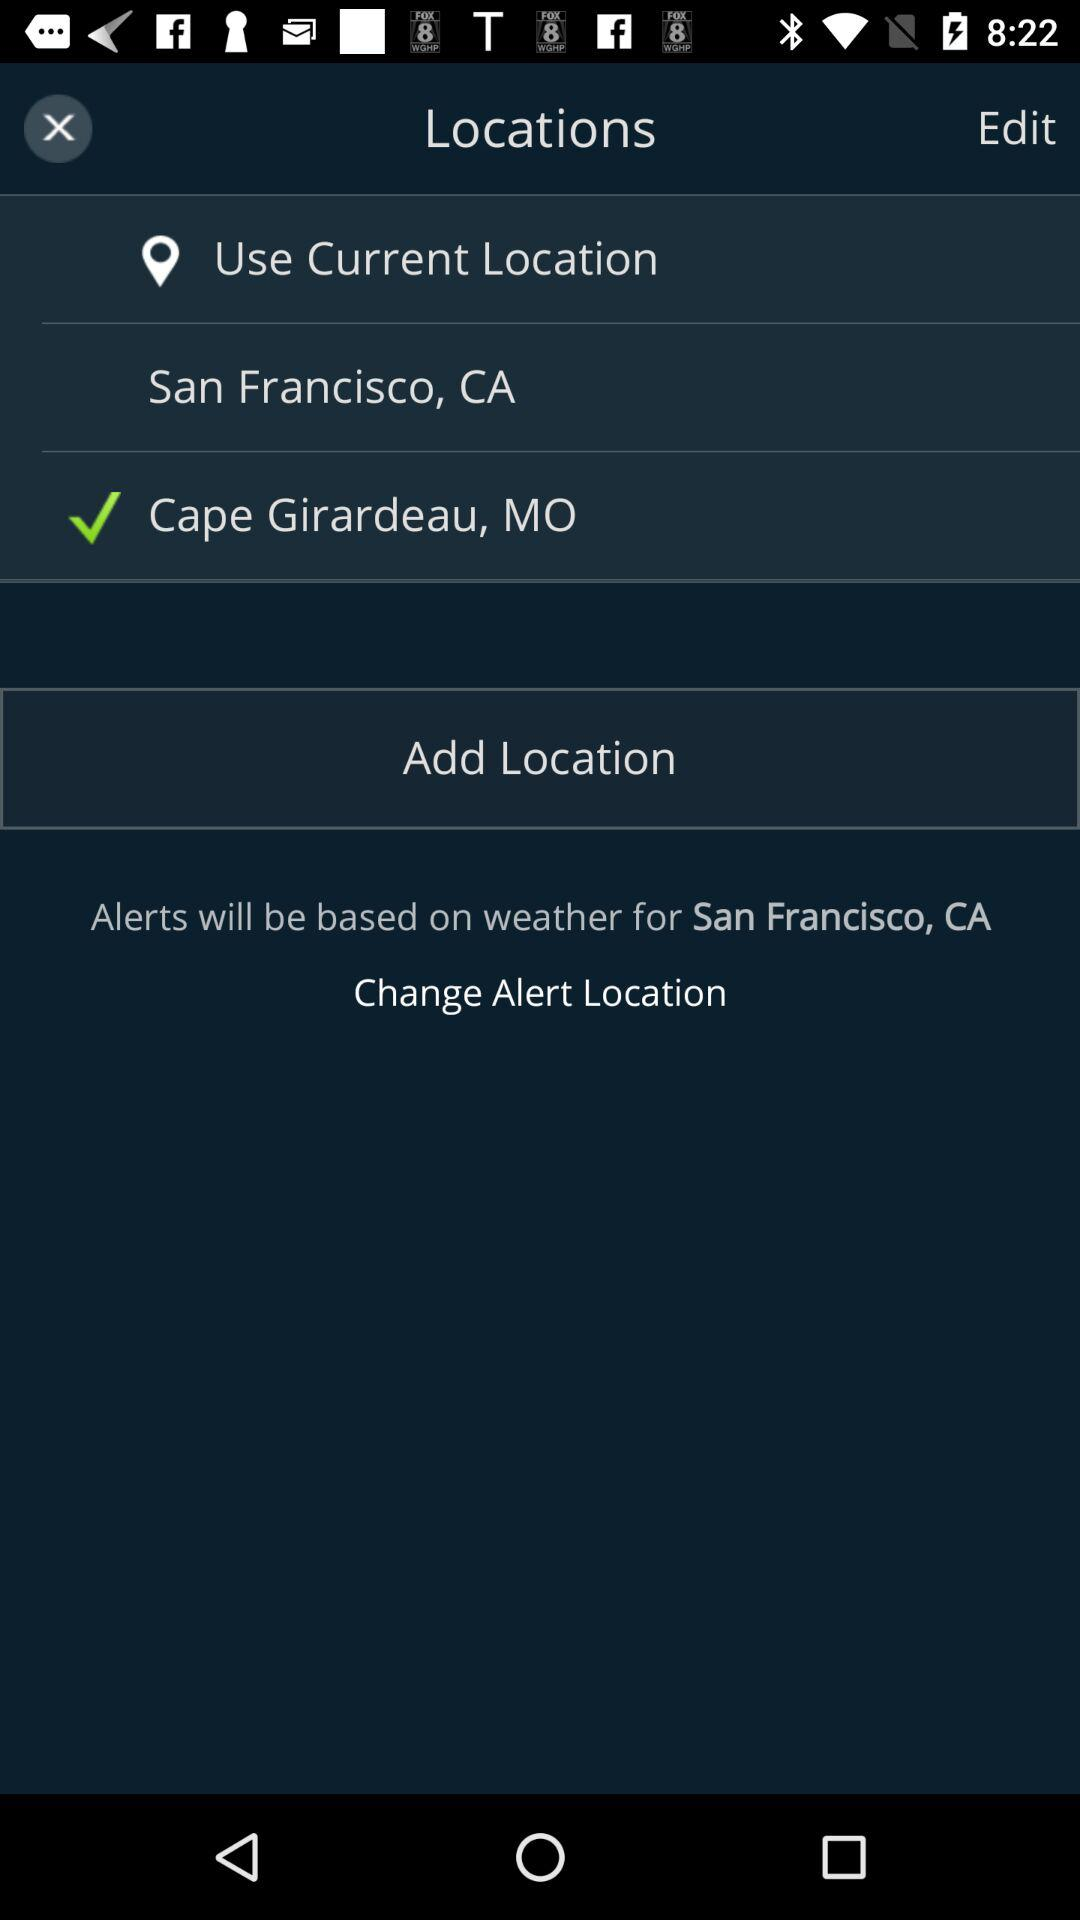How many locations are not checked?
Answer the question using a single word or phrase. 1 